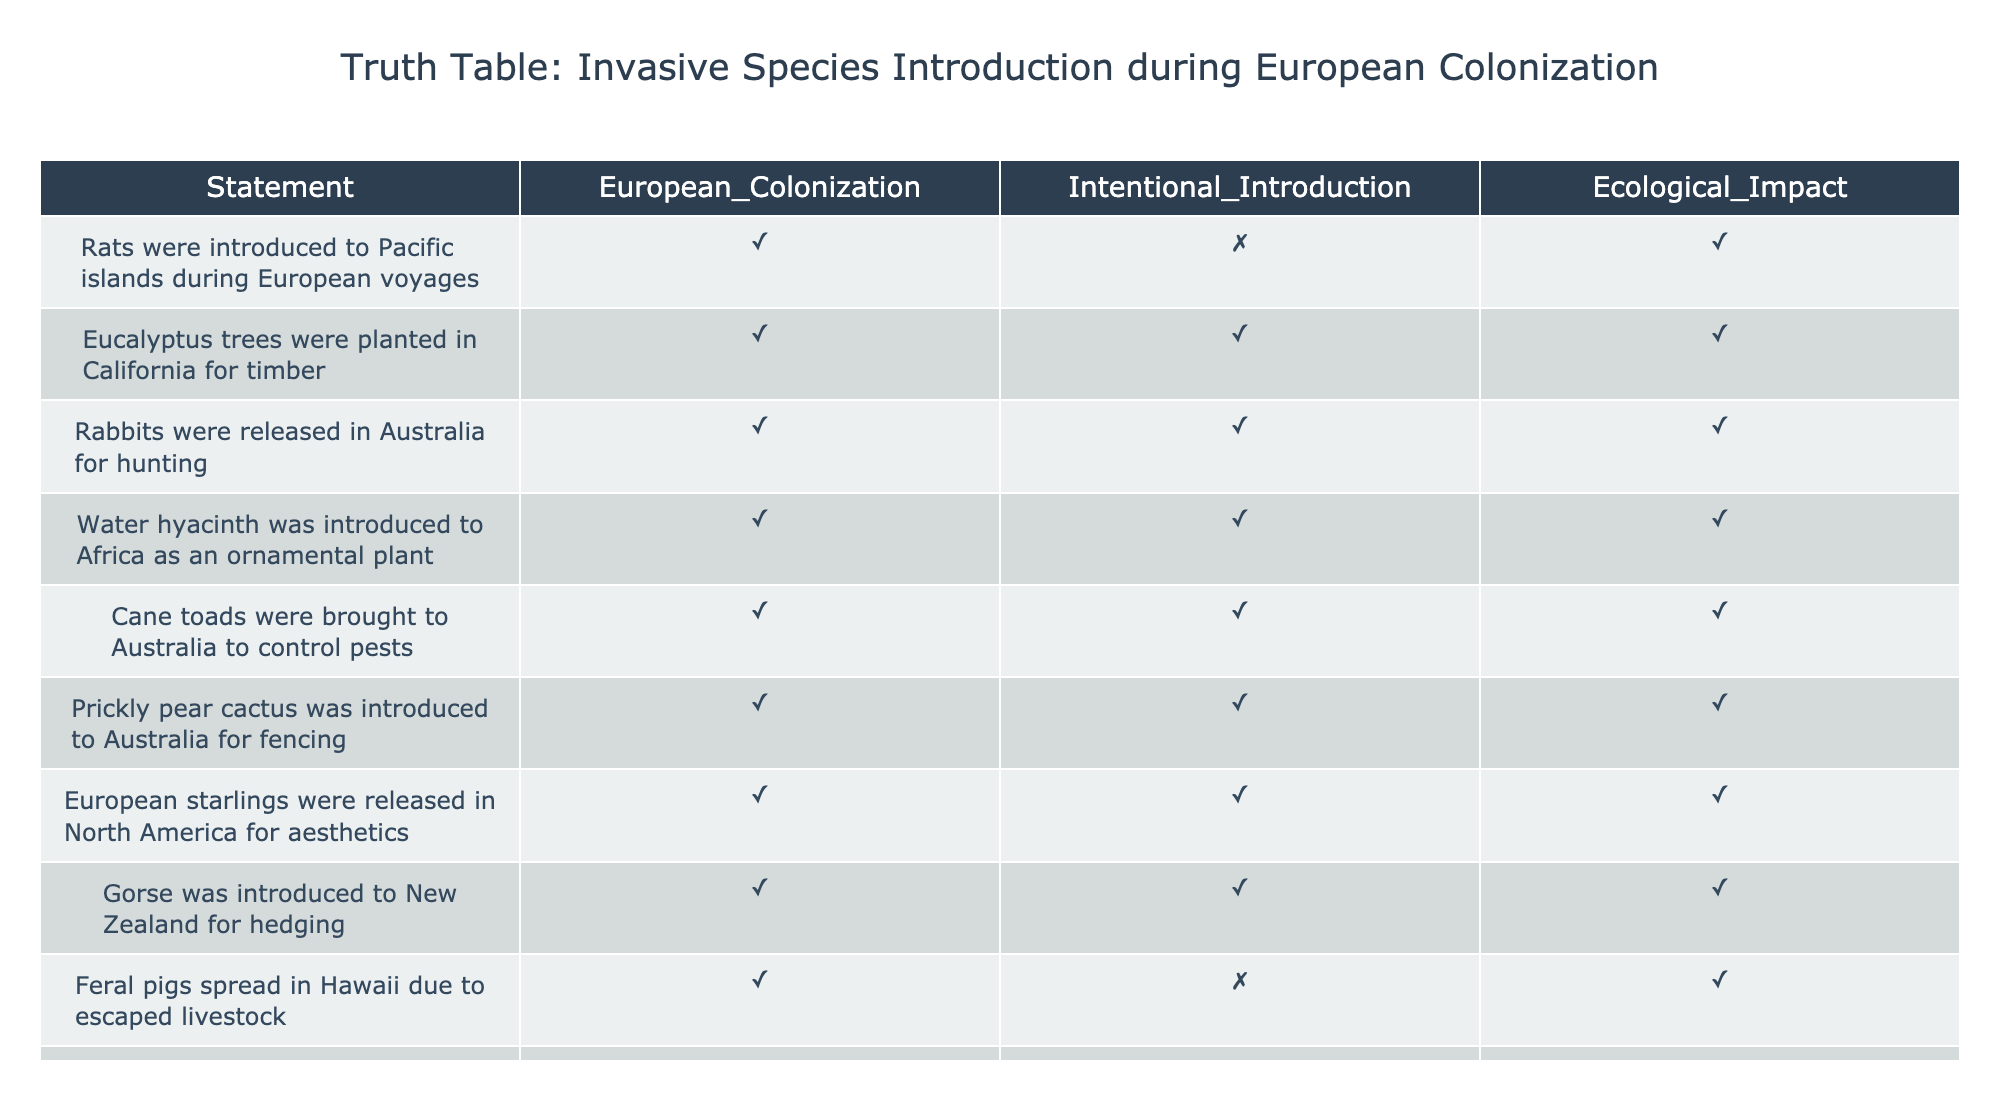What statements regarding invasive species were introduced during European colonization? The table shows multiple statements marked as true for European colonization. Specifically, the introduction of rats, rabbits, and several plant species like eucalyptus and gorse are all indicated as occurring during this period.
Answer: Rats, rabbits, eucalyptus trees, gorse, among others Is the statement "European starlings were released in North America for aesthetics" true or false? The table indicates that this statement is marked as true under both European colonization and intentional introduction, confirming its accuracy.
Answer: True How many statements indicate an intentional introduction of species? By checking the "Intentional Introduction" column, we find that there are 8 entries marked as true out of the total 10 entries, suggesting a high frequency of intentional introductions during colonization.
Answer: 8 Which species were introduced for a specific intent other than aesthetics? Analyzing the table, we see that Eucalyptus trees for timber, rabbits for hunting, cane toads for pest control, kudzu for erosion control, and prickly pear for fencing were introduced with specific intents.
Answer: Eucalyptus, rabbits, cane toads, kudzu, prickly pear What is the ecological impact of the species introduced intentionally? All species listed in the table have a true indication of ecological impact when introduced intentionally, showcasing that these introductions generally led to significant ecological consequences.
Answer: True 